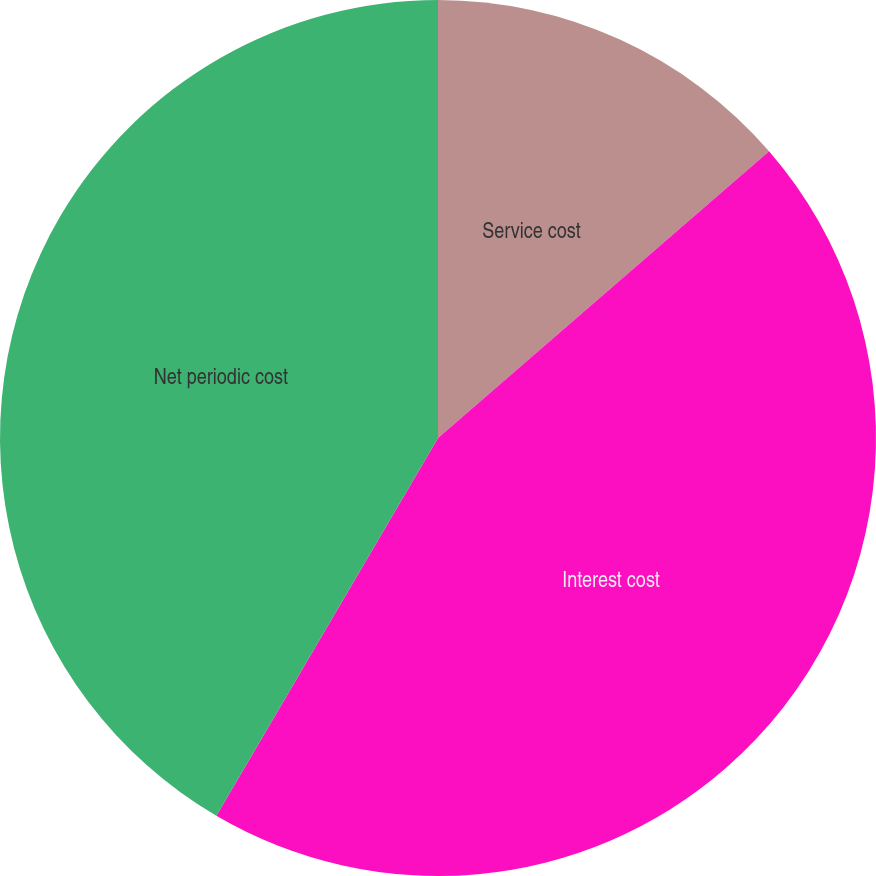<chart> <loc_0><loc_0><loc_500><loc_500><pie_chart><fcel>Service cost<fcel>Interest cost<fcel>Net periodic cost<nl><fcel>13.64%<fcel>44.81%<fcel>41.56%<nl></chart> 